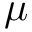<formula> <loc_0><loc_0><loc_500><loc_500>\mu</formula> 